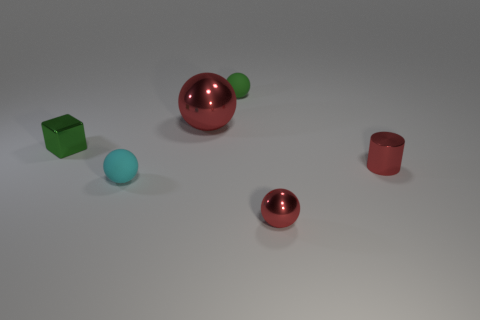How many things are either tiny green objects left of the tiny green ball or small shiny objects that are on the left side of the big red metal thing?
Offer a very short reply. 1. There is a cyan ball; is its size the same as the red ball that is behind the small red cylinder?
Offer a terse response. No. Is the material of the small green thing on the left side of the green rubber sphere the same as the red object in front of the tiny shiny cylinder?
Give a very brief answer. Yes. Are there the same number of red balls that are to the right of the large metallic thing and rubber balls to the right of the cylinder?
Your answer should be compact. No. How many small objects have the same color as the tiny metal ball?
Make the answer very short. 1. What material is the large thing that is the same color as the small shiny cylinder?
Your answer should be very brief. Metal. How many metallic things are either large red spheres or small blue things?
Give a very brief answer. 1. Does the small rubber object that is behind the shiny block have the same shape as the red metallic object in front of the red cylinder?
Your answer should be very brief. Yes. There is a small red metallic cylinder; what number of metallic balls are to the left of it?
Your response must be concise. 2. Are there any small cyan balls made of the same material as the green sphere?
Offer a terse response. Yes. 